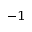<formula> <loc_0><loc_0><loc_500><loc_500>^ { - 1 }</formula> 